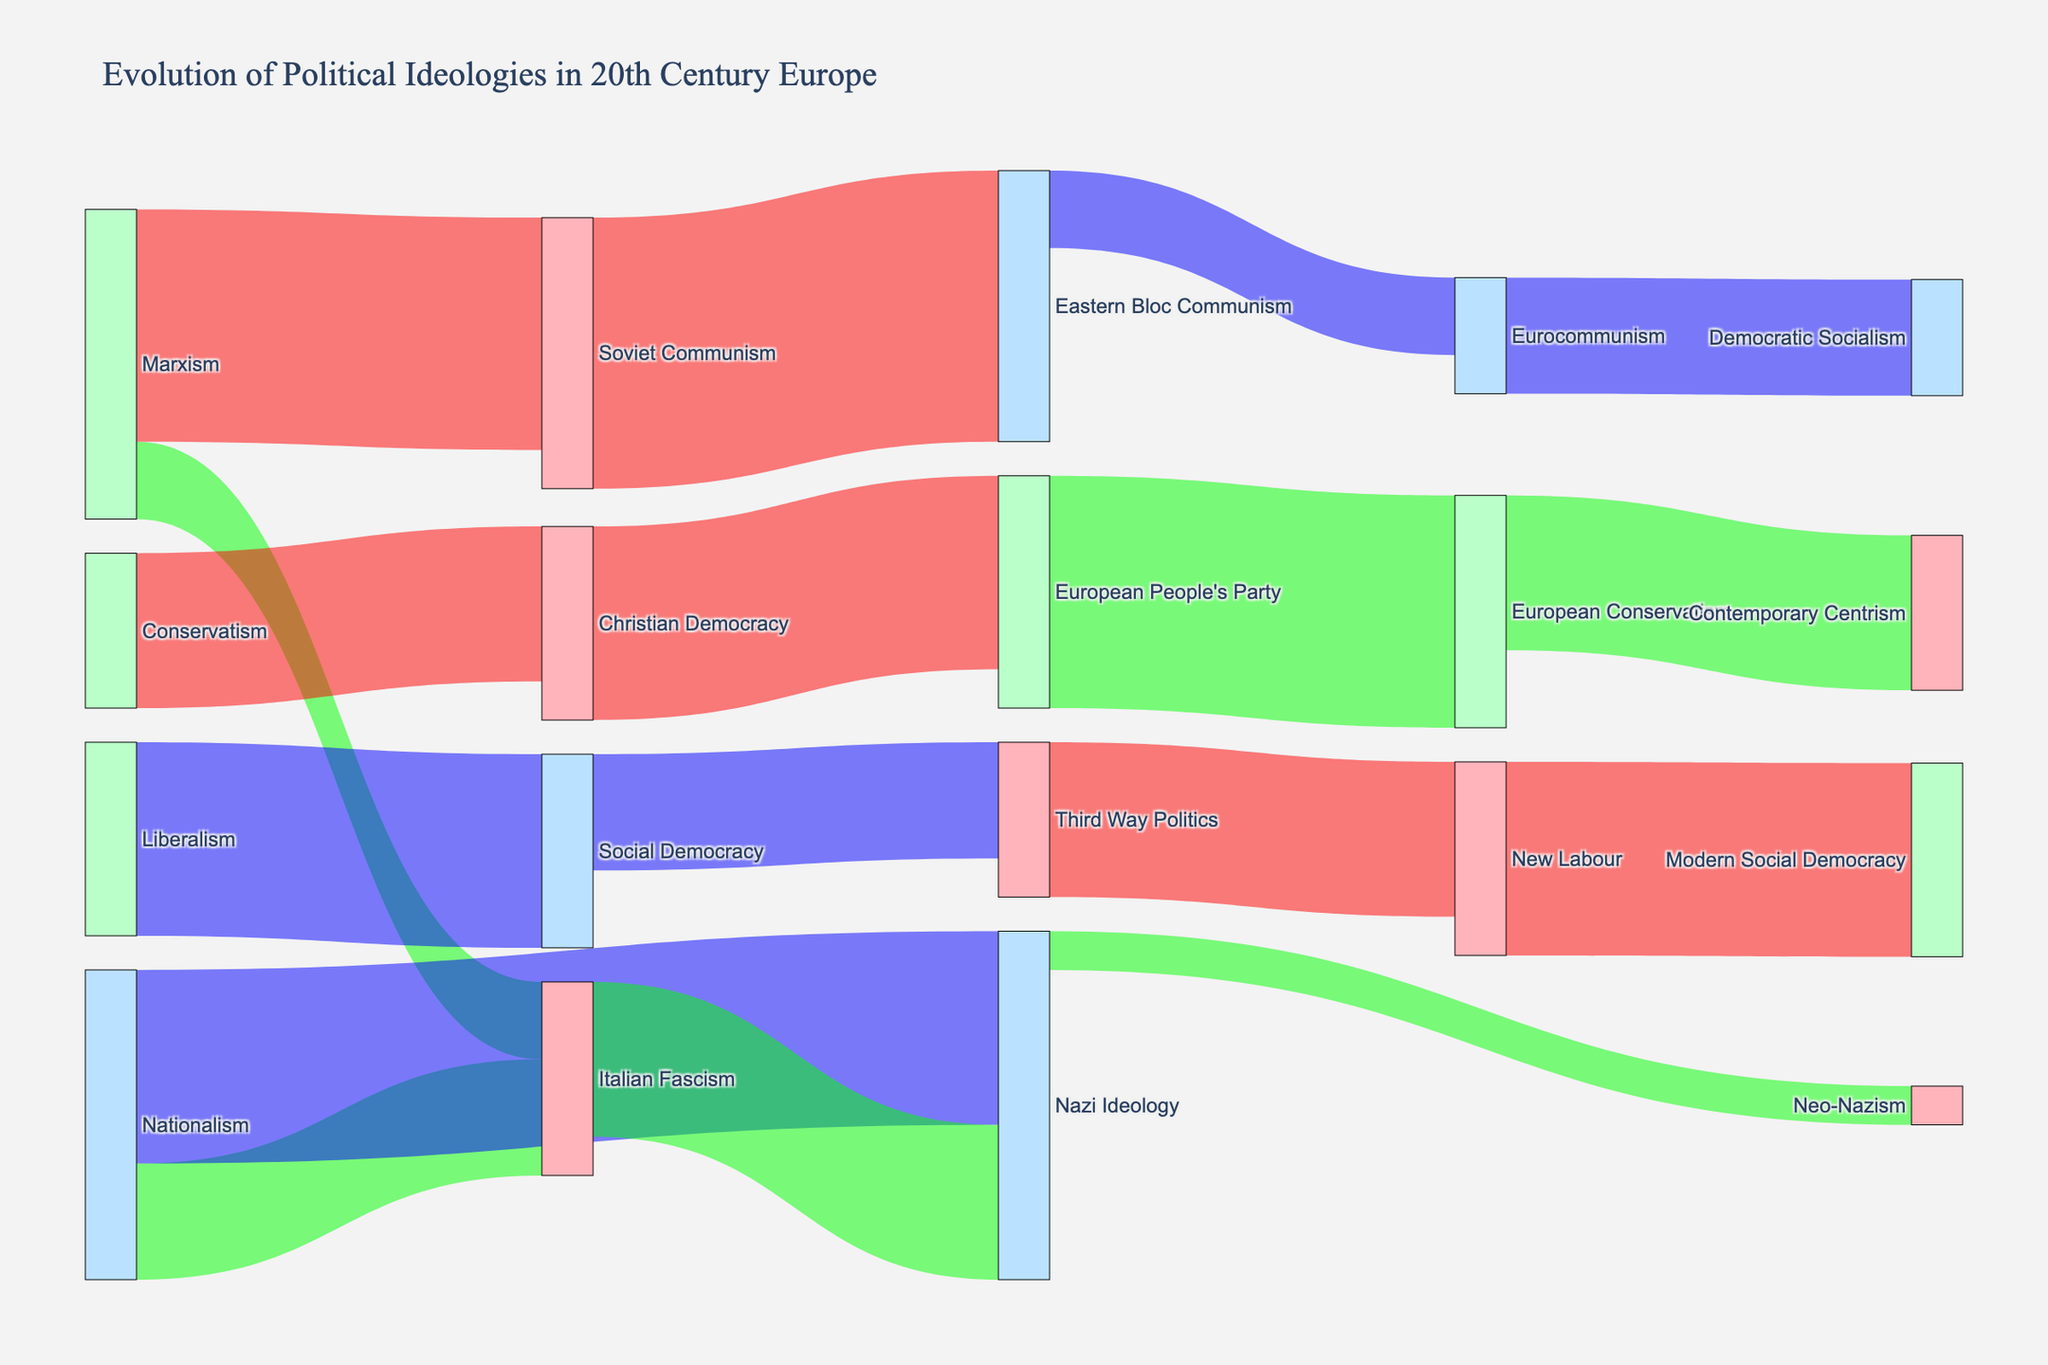What is the title of the Sankey diagram? The title is located at the top of the figure, summarizing the main focus of the diagram. It reads "Evolution of Political Ideologies in 20th Century Europe".
Answer: Evolution of Political Ideologies in 20th Century Europe What is the target ideology with the highest value originating from Marxism? To determine the target with the highest value from Marxism, locate Marxism as the source and find the target with the largest associated value. Soviet Communism has a value of 30.
Answer: Soviet Communism Which ideology has the highest number of connections as a source? Observe the number of paths originating from each ideology. Marxism has connections to Soviet Communism and Italian Fascism, totaling 2 connections, which is the highest.
Answer: Marxism How many flows lead to Neo-Nazism? Find the ideology Neo-Nazism and count the number of paths leading to it. There is only one flow from Nazi Ideology to Neo-Nazism.
Answer: 1 What is the cumulative value of connections leading from Nationalism? Sum the values of the connections from Nationalism: Italian Fascism (15) and Nazi Ideology (25). Therefore, 15 + 25 = 40.
Answer: 40 Which ideology has the largest downstream influence based on the value of connections? Look for the ideology with the highest combined value of all its outgoing connections. Soviet Communism connects to Eastern Bloc Communism with a value of 35.
Answer: Soviet Communism Which target ideology does Social Democracy flow into? Identify the target ideology that receives a flow from Social Democracy. There is a single connection from Social Democracy to Third Way Politics with a value of 15.
Answer: Third Way Politics Compare the values connected to Eastern Bloc Communism and Eurocommunism. Which one has higher values? Eastern Bloc Communism receives a value of 35 from Soviet Communism, while Eurocommunism receives a value of 10 from Eastern Bloc Communism. Thus, Eastern Bloc Communism has a higher value.
Answer: Eastern Bloc Communism What is the total value of connections related to European Conservatism? Locate the connections going into and out of European Conservatism. European Conservatism receives a single connection from the European People's Party with a value of 30.
Answer: 30 Which source ideology has the lowest value flowing to its targets? Examine the values of all flows from source ideologies and determine which has the lowest. Nazi Ideology has a flow to Neo-Nazism with a value of 5.
Answer: Nazi Ideology 